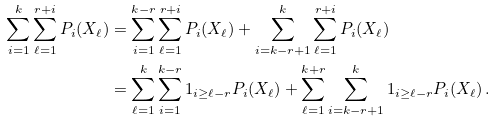<formula> <loc_0><loc_0><loc_500><loc_500>\sum _ { i = 1 } ^ { k } \sum _ { \ell = 1 } ^ { r + i } P _ { i } ( X _ { \ell } ) & = \sum _ { i = 1 } ^ { k - r } \sum _ { \ell = 1 } ^ { r + i } P _ { i } ( X _ { \ell } ) + \sum _ { i = k - r + 1 } ^ { k } \sum _ { \ell = 1 } ^ { r + i } P _ { i } ( X _ { \ell } ) \\ & = \sum _ { \ell = 1 } ^ { k } \sum _ { i = 1 } ^ { k - r } { 1 } _ { i \geq \ell - r } P _ { i } ( X _ { \ell } ) + \sum _ { \ell = 1 } ^ { k + r } \sum _ { i = k - r + 1 } ^ { k } { 1 } _ { i \geq \ell - r } P _ { i } ( X _ { \ell } ) \, .</formula> 